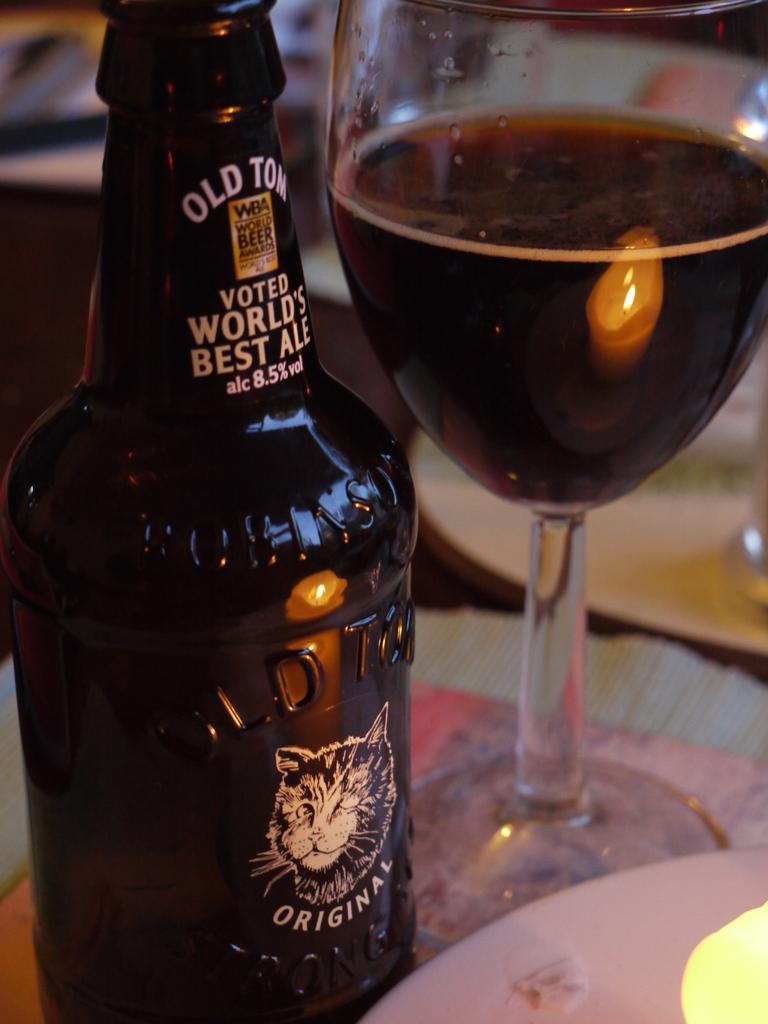What is in the bottle?
Your answer should be compact. Ale. Is this the world's best ale?
Offer a very short reply. Yes. 